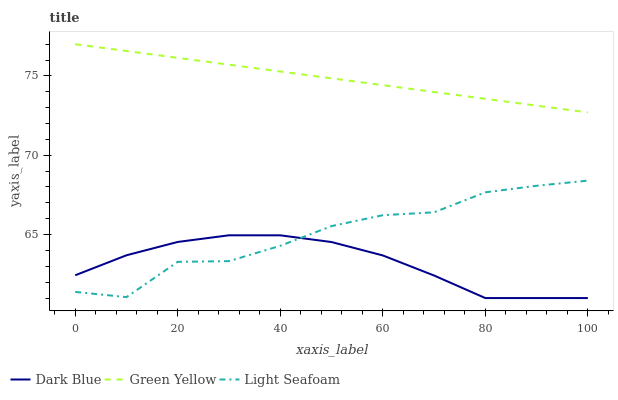Does Dark Blue have the minimum area under the curve?
Answer yes or no. Yes. Does Green Yellow have the maximum area under the curve?
Answer yes or no. Yes. Does Light Seafoam have the minimum area under the curve?
Answer yes or no. No. Does Light Seafoam have the maximum area under the curve?
Answer yes or no. No. Is Green Yellow the smoothest?
Answer yes or no. Yes. Is Light Seafoam the roughest?
Answer yes or no. Yes. Is Light Seafoam the smoothest?
Answer yes or no. No. Is Green Yellow the roughest?
Answer yes or no. No. Does Light Seafoam have the lowest value?
Answer yes or no. No. Does Light Seafoam have the highest value?
Answer yes or no. No. Is Light Seafoam less than Green Yellow?
Answer yes or no. Yes. Is Green Yellow greater than Light Seafoam?
Answer yes or no. Yes. Does Light Seafoam intersect Green Yellow?
Answer yes or no. No. 